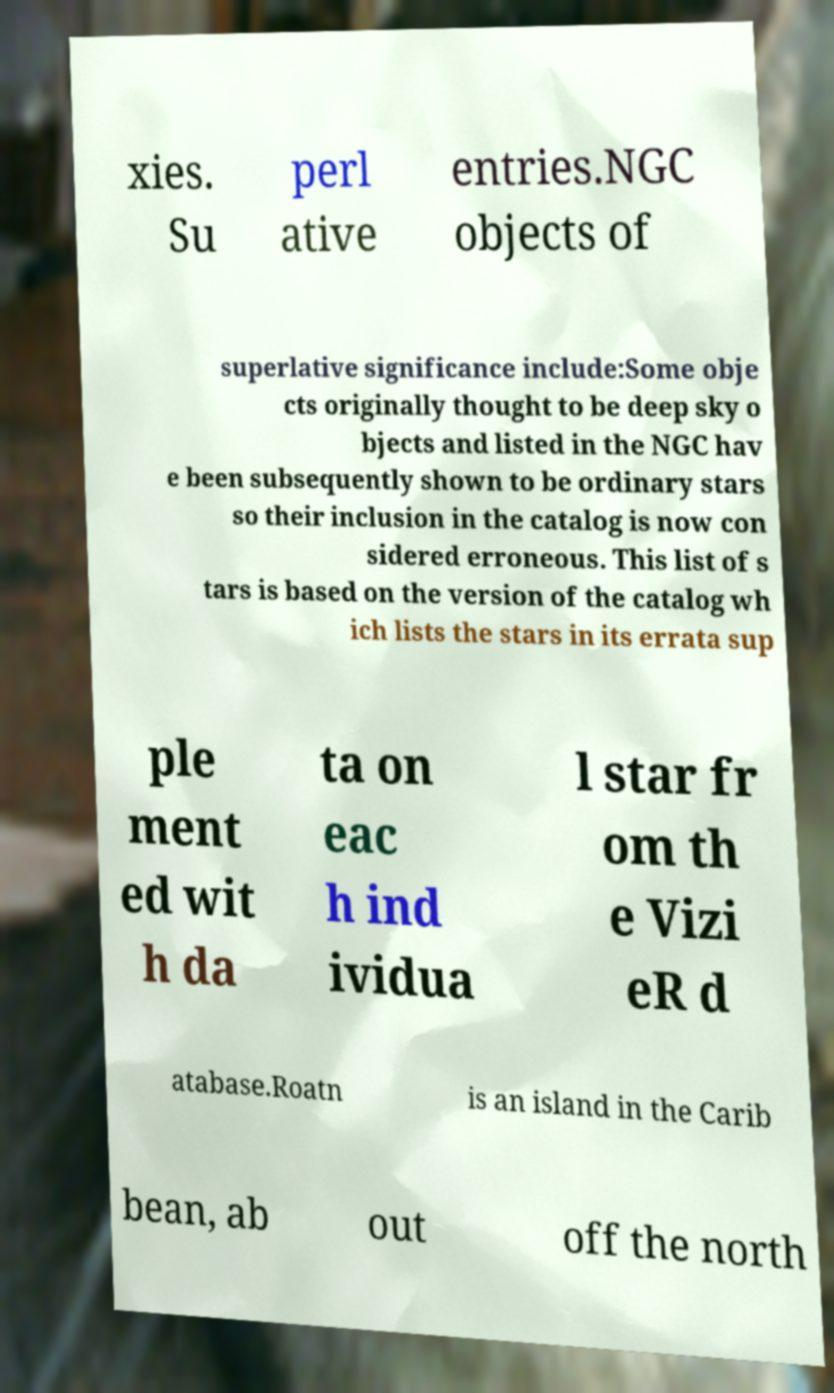There's text embedded in this image that I need extracted. Can you transcribe it verbatim? xies. Su perl ative entries.NGC objects of superlative significance include:Some obje cts originally thought to be deep sky o bjects and listed in the NGC hav e been subsequently shown to be ordinary stars so their inclusion in the catalog is now con sidered erroneous. This list of s tars is based on the version of the catalog wh ich lists the stars in its errata sup ple ment ed wit h da ta on eac h ind ividua l star fr om th e Vizi eR d atabase.Roatn is an island in the Carib bean, ab out off the north 